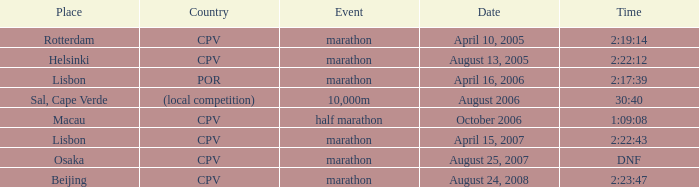What is the Country of the 10,000m Event? (local competition). 